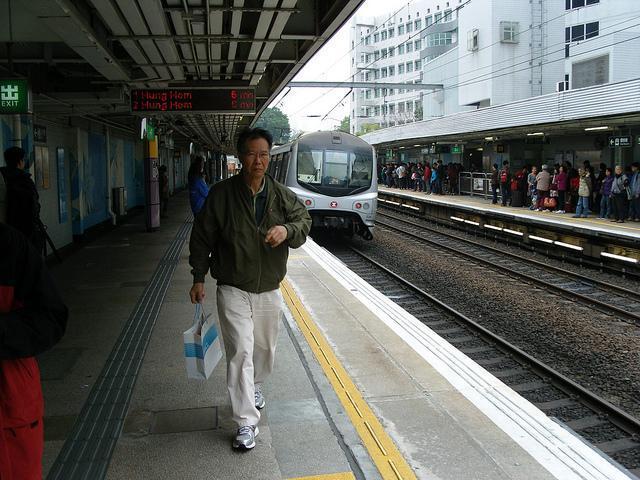How many people are in the picture?
Give a very brief answer. 4. 